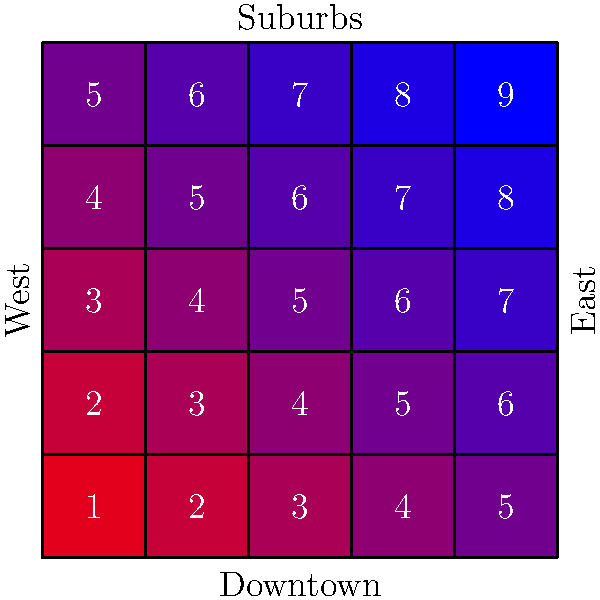Based on the heat map of property values in different city zones, which area shows the highest property values, and what strategy would you recommend for a real estate investor looking to maximize potential returns? To answer this question, we need to analyze the heat map and consider real estate investment strategies:

1. Interpreting the heat map:
   - The heat map uses a color gradient from blue (lower values) to red (higher values).
   - Each cell represents a different zone in the city, with numbers indicating property values.

2. Identifying the highest property values:
   - The highest value on the map is 9, located in the bottom-right corner.
   - This corresponds to the Eastern Suburbs of the city.

3. Understanding the overall trend:
   - Property values generally increase from top-left (Northwest) to bottom-right (Southeast).
   - Downtown areas (bottom) have higher values compared to the suburbs (top).
   - Eastern areas have higher values compared to Western areas.

4. Investment strategy considerations:
   - Highest value areas (Eastern Suburbs) may offer stable investments but with lower potential for appreciation.
   - Areas adjacent to high-value zones (e.g., cells with values 7 and 8) may offer a balance of current value and potential appreciation.
   - Lower-value areas in the Northwest might offer higher potential returns but with more risk.

5. Recommended strategy:
   - For an investor looking to maximize potential returns, focus on areas showing moderate values (6-7) adjacent to high-value zones.
   - These areas, particularly in the central-eastern part of the map, offer a balance of current value and potential for appreciation as development spreads from the high-value zones.

6. Additional considerations:
   - Diversification across different zones can help balance risk and potential returns.
   - Further market analysis of specific neighborhoods within these zones would be necessary for more precise investment decisions.
Answer: Invest in moderate-value areas (6-7) adjacent to high-value Eastern Suburbs for balanced returns and appreciation potential. 